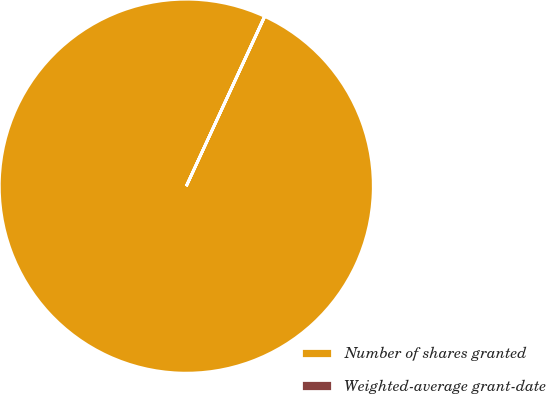<chart> <loc_0><loc_0><loc_500><loc_500><pie_chart><fcel>Number of shares granted<fcel>Weighted-average grant-date<nl><fcel>99.98%<fcel>0.02%<nl></chart> 